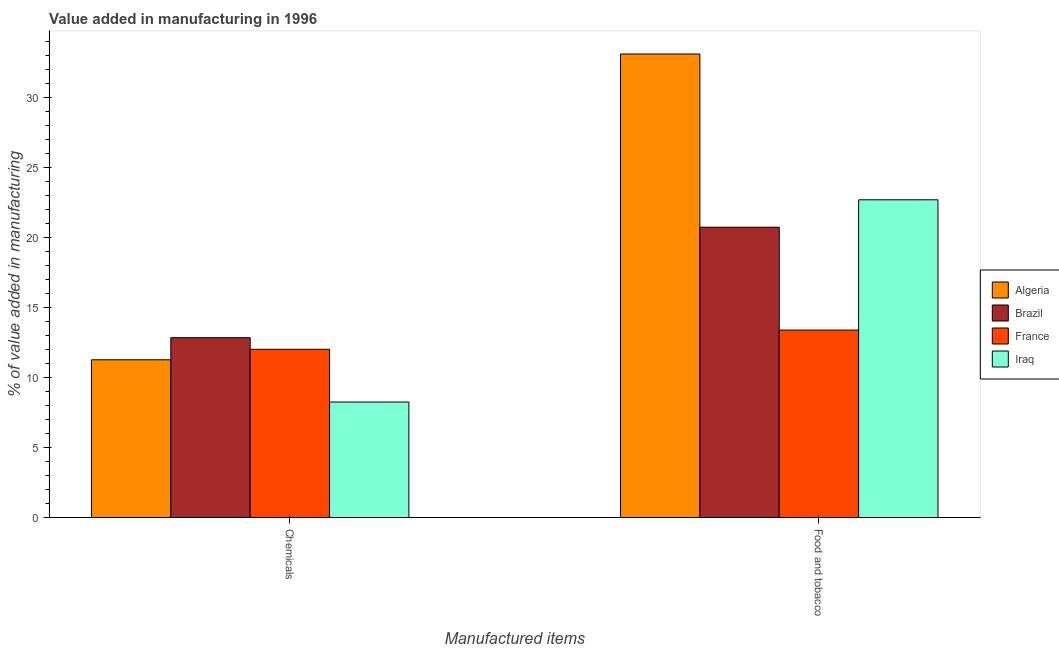How many groups of bars are there?
Your answer should be compact. 2. How many bars are there on the 1st tick from the left?
Your response must be concise. 4. What is the label of the 2nd group of bars from the left?
Offer a very short reply. Food and tobacco. What is the value added by  manufacturing chemicals in France?
Your response must be concise. 12.03. Across all countries, what is the maximum value added by manufacturing food and tobacco?
Keep it short and to the point. 33.14. Across all countries, what is the minimum value added by  manufacturing chemicals?
Make the answer very short. 8.26. In which country was the value added by  manufacturing chemicals minimum?
Offer a terse response. Iraq. What is the total value added by manufacturing food and tobacco in the graph?
Provide a short and direct response. 90.01. What is the difference between the value added by  manufacturing chemicals in Brazil and that in France?
Your response must be concise. 0.83. What is the difference between the value added by manufacturing food and tobacco in Iraq and the value added by  manufacturing chemicals in France?
Your answer should be very brief. 10.69. What is the average value added by manufacturing food and tobacco per country?
Your answer should be compact. 22.5. What is the difference between the value added by  manufacturing chemicals and value added by manufacturing food and tobacco in Brazil?
Keep it short and to the point. -7.9. In how many countries, is the value added by manufacturing food and tobacco greater than 29 %?
Provide a succinct answer. 1. What is the ratio of the value added by  manufacturing chemicals in Algeria to that in France?
Provide a short and direct response. 0.94. What does the 4th bar from the left in Chemicals represents?
Offer a very short reply. Iraq. What does the 4th bar from the right in Food and tobacco represents?
Your response must be concise. Algeria. How many bars are there?
Your answer should be compact. 8. Are all the bars in the graph horizontal?
Give a very brief answer. No. What is the difference between two consecutive major ticks on the Y-axis?
Provide a short and direct response. 5. Are the values on the major ticks of Y-axis written in scientific E-notation?
Provide a succinct answer. No. Where does the legend appear in the graph?
Make the answer very short. Center right. What is the title of the graph?
Give a very brief answer. Value added in manufacturing in 1996. Does "Korea (Republic)" appear as one of the legend labels in the graph?
Keep it short and to the point. No. What is the label or title of the X-axis?
Make the answer very short. Manufactured items. What is the label or title of the Y-axis?
Give a very brief answer. % of value added in manufacturing. What is the % of value added in manufacturing of Algeria in Chemicals?
Offer a terse response. 11.28. What is the % of value added in manufacturing of Brazil in Chemicals?
Your response must be concise. 12.86. What is the % of value added in manufacturing of France in Chemicals?
Give a very brief answer. 12.03. What is the % of value added in manufacturing of Iraq in Chemicals?
Ensure brevity in your answer.  8.26. What is the % of value added in manufacturing of Algeria in Food and tobacco?
Your answer should be very brief. 33.14. What is the % of value added in manufacturing in Brazil in Food and tobacco?
Ensure brevity in your answer.  20.76. What is the % of value added in manufacturing in France in Food and tobacco?
Offer a very short reply. 13.4. What is the % of value added in manufacturing in Iraq in Food and tobacco?
Make the answer very short. 22.72. Across all Manufactured items, what is the maximum % of value added in manufacturing of Algeria?
Give a very brief answer. 33.14. Across all Manufactured items, what is the maximum % of value added in manufacturing in Brazil?
Provide a short and direct response. 20.76. Across all Manufactured items, what is the maximum % of value added in manufacturing in France?
Offer a terse response. 13.4. Across all Manufactured items, what is the maximum % of value added in manufacturing of Iraq?
Your answer should be very brief. 22.72. Across all Manufactured items, what is the minimum % of value added in manufacturing of Algeria?
Make the answer very short. 11.28. Across all Manufactured items, what is the minimum % of value added in manufacturing in Brazil?
Provide a short and direct response. 12.86. Across all Manufactured items, what is the minimum % of value added in manufacturing of France?
Provide a succinct answer. 12.03. Across all Manufactured items, what is the minimum % of value added in manufacturing of Iraq?
Keep it short and to the point. 8.26. What is the total % of value added in manufacturing of Algeria in the graph?
Keep it short and to the point. 44.42. What is the total % of value added in manufacturing of Brazil in the graph?
Give a very brief answer. 33.61. What is the total % of value added in manufacturing of France in the graph?
Ensure brevity in your answer.  25.43. What is the total % of value added in manufacturing of Iraq in the graph?
Make the answer very short. 30.97. What is the difference between the % of value added in manufacturing in Algeria in Chemicals and that in Food and tobacco?
Provide a short and direct response. -21.86. What is the difference between the % of value added in manufacturing in Brazil in Chemicals and that in Food and tobacco?
Provide a succinct answer. -7.9. What is the difference between the % of value added in manufacturing of France in Chemicals and that in Food and tobacco?
Provide a succinct answer. -1.37. What is the difference between the % of value added in manufacturing of Iraq in Chemicals and that in Food and tobacco?
Ensure brevity in your answer.  -14.46. What is the difference between the % of value added in manufacturing in Algeria in Chemicals and the % of value added in manufacturing in Brazil in Food and tobacco?
Your answer should be very brief. -9.48. What is the difference between the % of value added in manufacturing of Algeria in Chemicals and the % of value added in manufacturing of France in Food and tobacco?
Offer a very short reply. -2.12. What is the difference between the % of value added in manufacturing of Algeria in Chemicals and the % of value added in manufacturing of Iraq in Food and tobacco?
Provide a short and direct response. -11.44. What is the difference between the % of value added in manufacturing of Brazil in Chemicals and the % of value added in manufacturing of France in Food and tobacco?
Give a very brief answer. -0.55. What is the difference between the % of value added in manufacturing of Brazil in Chemicals and the % of value added in manufacturing of Iraq in Food and tobacco?
Give a very brief answer. -9.86. What is the difference between the % of value added in manufacturing of France in Chemicals and the % of value added in manufacturing of Iraq in Food and tobacco?
Ensure brevity in your answer.  -10.69. What is the average % of value added in manufacturing of Algeria per Manufactured items?
Ensure brevity in your answer.  22.21. What is the average % of value added in manufacturing in Brazil per Manufactured items?
Give a very brief answer. 16.81. What is the average % of value added in manufacturing of France per Manufactured items?
Keep it short and to the point. 12.72. What is the average % of value added in manufacturing of Iraq per Manufactured items?
Make the answer very short. 15.49. What is the difference between the % of value added in manufacturing in Algeria and % of value added in manufacturing in Brazil in Chemicals?
Give a very brief answer. -1.58. What is the difference between the % of value added in manufacturing of Algeria and % of value added in manufacturing of France in Chemicals?
Your response must be concise. -0.75. What is the difference between the % of value added in manufacturing of Algeria and % of value added in manufacturing of Iraq in Chemicals?
Keep it short and to the point. 3.02. What is the difference between the % of value added in manufacturing of Brazil and % of value added in manufacturing of France in Chemicals?
Your answer should be compact. 0.83. What is the difference between the % of value added in manufacturing of Brazil and % of value added in manufacturing of Iraq in Chemicals?
Give a very brief answer. 4.6. What is the difference between the % of value added in manufacturing of France and % of value added in manufacturing of Iraq in Chemicals?
Your answer should be very brief. 3.77. What is the difference between the % of value added in manufacturing of Algeria and % of value added in manufacturing of Brazil in Food and tobacco?
Make the answer very short. 12.38. What is the difference between the % of value added in manufacturing in Algeria and % of value added in manufacturing in France in Food and tobacco?
Your answer should be compact. 19.73. What is the difference between the % of value added in manufacturing of Algeria and % of value added in manufacturing of Iraq in Food and tobacco?
Keep it short and to the point. 10.42. What is the difference between the % of value added in manufacturing in Brazil and % of value added in manufacturing in France in Food and tobacco?
Ensure brevity in your answer.  7.35. What is the difference between the % of value added in manufacturing of Brazil and % of value added in manufacturing of Iraq in Food and tobacco?
Provide a short and direct response. -1.96. What is the difference between the % of value added in manufacturing of France and % of value added in manufacturing of Iraq in Food and tobacco?
Offer a very short reply. -9.31. What is the ratio of the % of value added in manufacturing in Algeria in Chemicals to that in Food and tobacco?
Keep it short and to the point. 0.34. What is the ratio of the % of value added in manufacturing in Brazil in Chemicals to that in Food and tobacco?
Make the answer very short. 0.62. What is the ratio of the % of value added in manufacturing of France in Chemicals to that in Food and tobacco?
Your answer should be very brief. 0.9. What is the ratio of the % of value added in manufacturing of Iraq in Chemicals to that in Food and tobacco?
Provide a succinct answer. 0.36. What is the difference between the highest and the second highest % of value added in manufacturing of Algeria?
Your answer should be compact. 21.86. What is the difference between the highest and the second highest % of value added in manufacturing of Brazil?
Ensure brevity in your answer.  7.9. What is the difference between the highest and the second highest % of value added in manufacturing in France?
Your answer should be very brief. 1.37. What is the difference between the highest and the second highest % of value added in manufacturing in Iraq?
Offer a terse response. 14.46. What is the difference between the highest and the lowest % of value added in manufacturing in Algeria?
Provide a succinct answer. 21.86. What is the difference between the highest and the lowest % of value added in manufacturing in Brazil?
Give a very brief answer. 7.9. What is the difference between the highest and the lowest % of value added in manufacturing of France?
Offer a terse response. 1.37. What is the difference between the highest and the lowest % of value added in manufacturing in Iraq?
Your response must be concise. 14.46. 